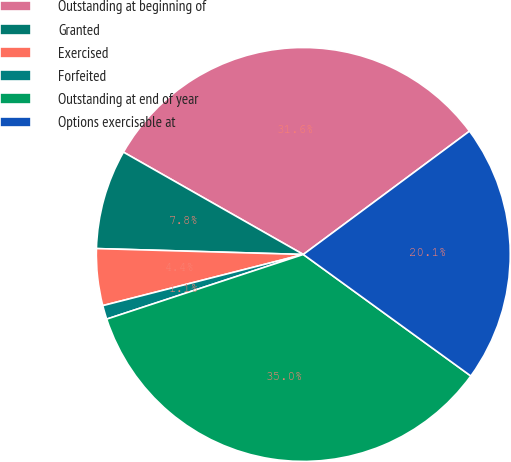Convert chart. <chart><loc_0><loc_0><loc_500><loc_500><pie_chart><fcel>Outstanding at beginning of<fcel>Granted<fcel>Exercised<fcel>Forfeited<fcel>Outstanding at end of year<fcel>Options exercisable at<nl><fcel>31.61%<fcel>7.78%<fcel>4.43%<fcel>1.08%<fcel>34.96%<fcel>20.15%<nl></chart> 